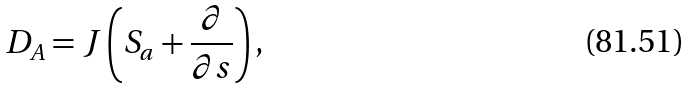Convert formula to latex. <formula><loc_0><loc_0><loc_500><loc_500>D _ { A } = J \left ( S _ { a } + \frac { \partial } { \partial s } \right ) ,</formula> 